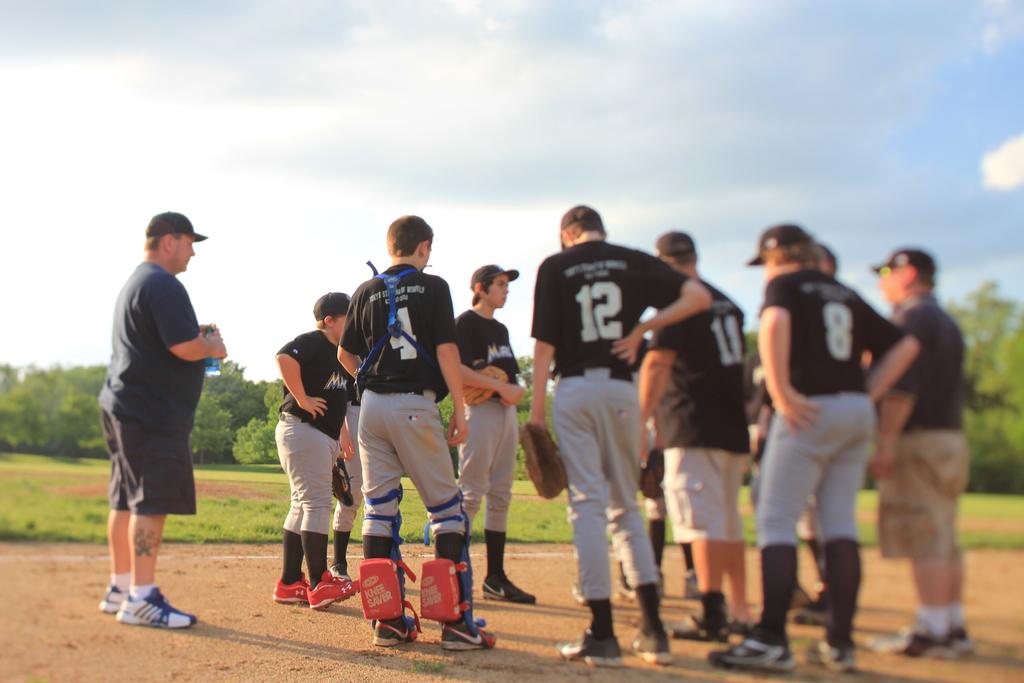What number is on the jersey of the player between 4 and 8?
Provide a short and direct response. 12. 